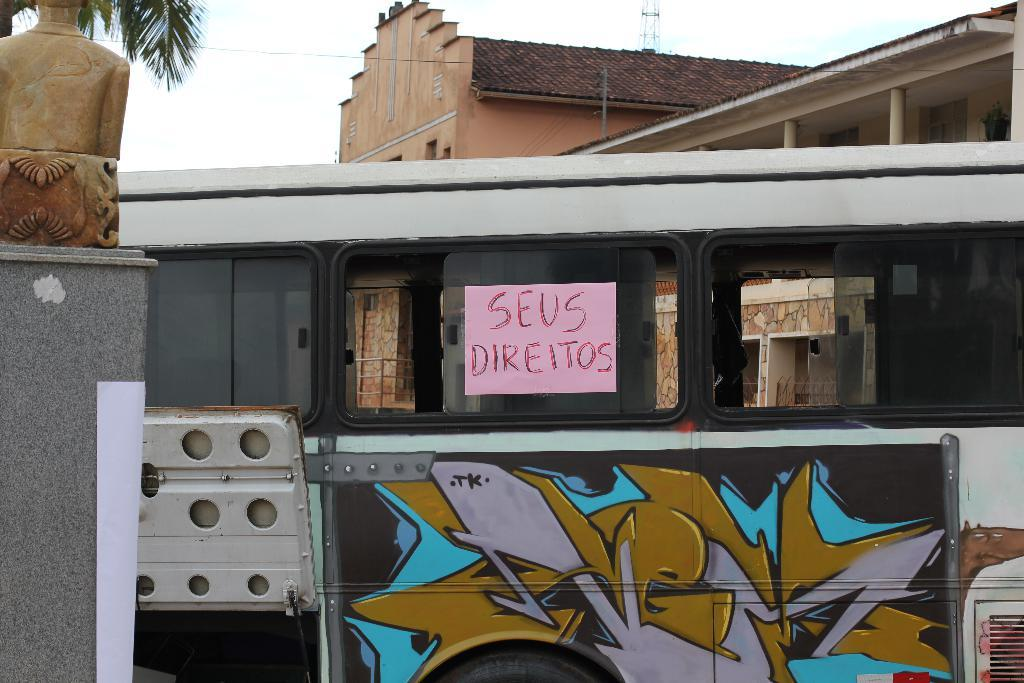What is the main subject that appears to be truncated in the image? There is a vehicle in the image, but it appears to be truncated. What else can be seen in the image besides the vehicle? There is a poster, a painting, a statue, a wall, leaves, a building, and sky visible in the image. What type of tooth is being used to cut the beef in the image? There is no tooth or beef present in the image. How many eyes can be seen on the statue in the image? There is no mention of eyes on the statue in the image, as the facts provided do not specify any details about the statue's features. 